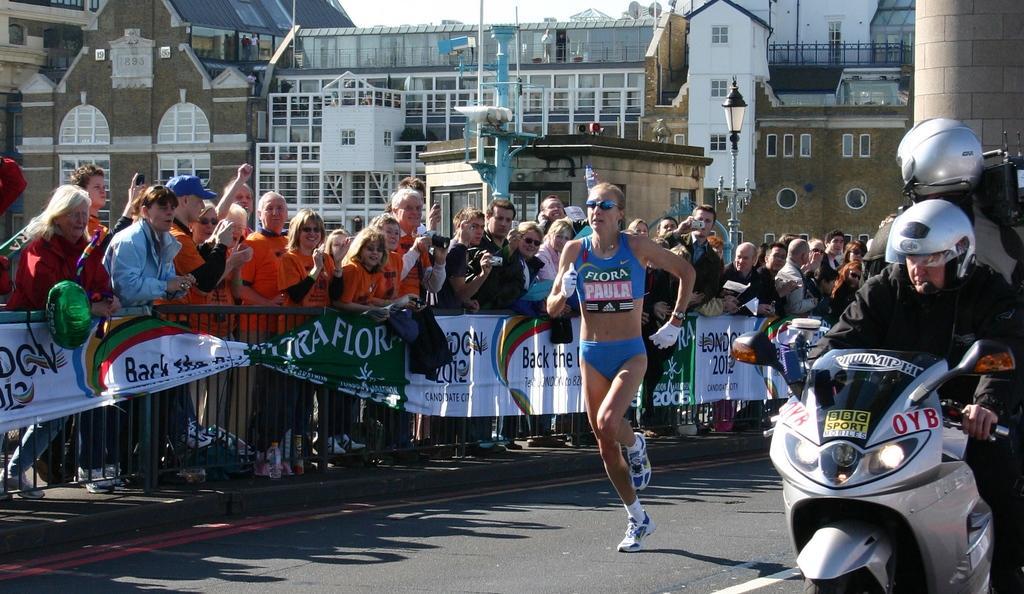Please provide a concise description of this image. A woman wearing blue dress, gloves, goggles are running on the road. On the right side a person wearing helmet is riding a motor cycle. Behind him another person is wearing helmet is holding a video camera. On the left side many people are standing. There is a railing. On the railing there are banner. In the background there are many buildings, windows, street light poles and railings. 